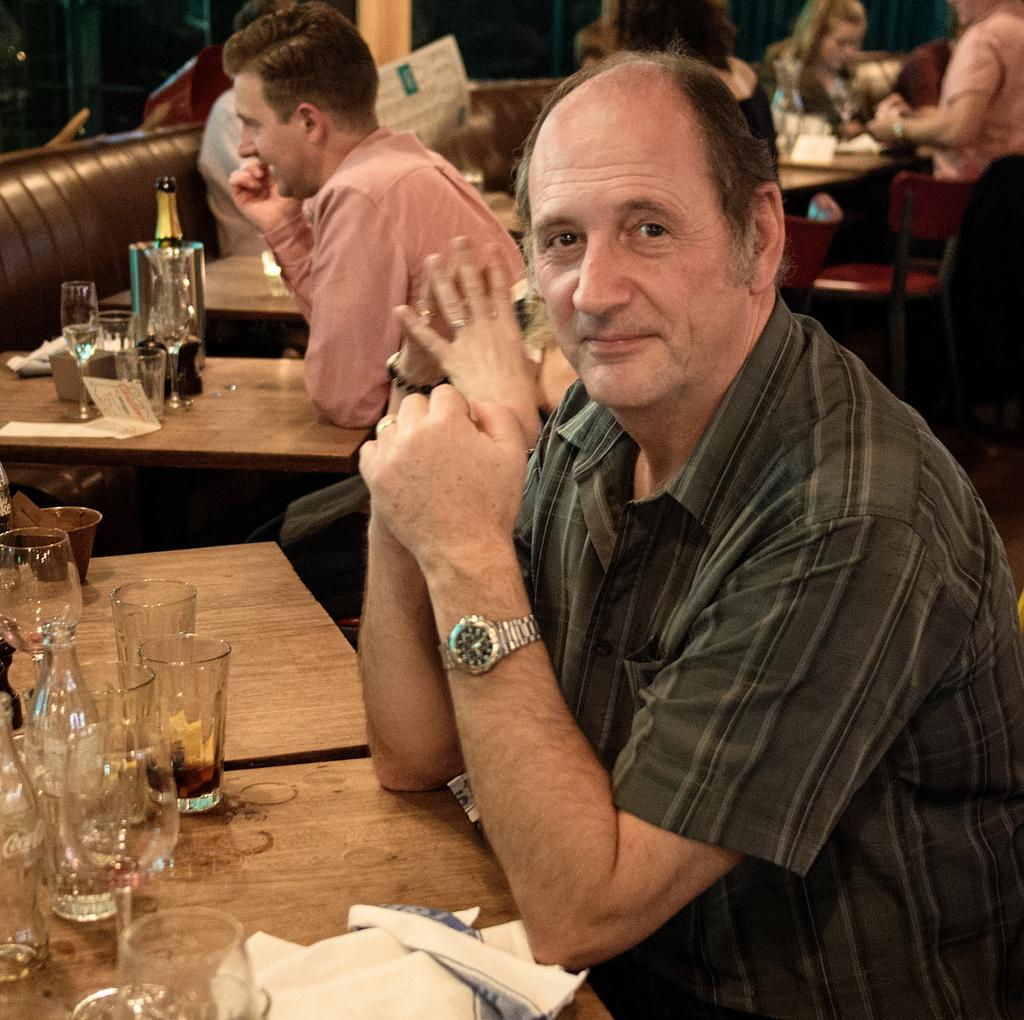What are the people in the image doing? The people in the image are sitting. What can be seen on the tables in the image? There are bottles and glasses on the tables in the image. What type of furniture is present in the image? There are chairs and sofas in the image. Can you tell me how many kittens are sitting on the sofas in the image? There are no kittens present in the image; only people are sitting on the sofas. What type of berry can be seen in the hands of the mother in the image? There is no mother or berry present in the image. 